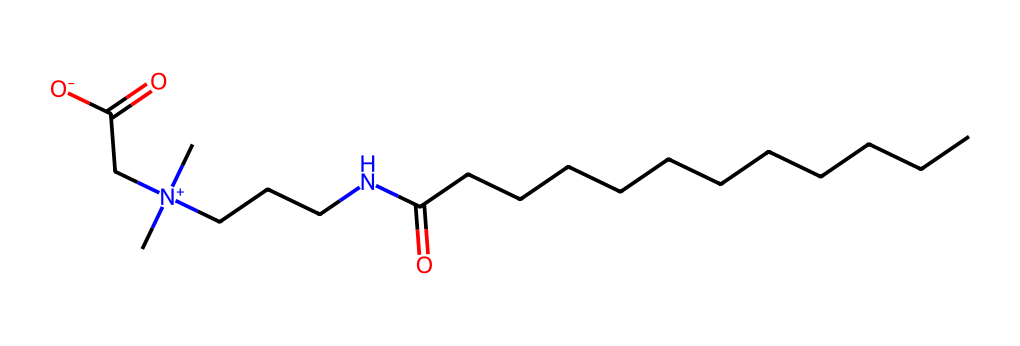What is the total number of carbon atoms in cocamidopropyl betaine? By analyzing the SMILES representation, we can count the carbon atoms present. The chain "CCCCCCCCCCCC" indicates 12 carbon atoms, plus 2 additional carbon atoms from "NCCC" and one more in the "CC(=O)" section, bringing the total to 15 carbon atoms.
Answer: 15 How many nitrogen atoms are present in cocamidopropyl betaine? The SMILES shows "N" in two locations: one in the "NCCC" part and another as "[N+]" in the same sequence. Thus, there are 2 nitrogen atoms in total.
Answer: 2 What type of surfactant is cocamidopropyl betaine? Cocamidopropyl betaine contains a quaternary nitrogen ("[N+]") linked to the hydrocarbon chain. This configuration indicates that it is a cationic surfactant, making it soluble in water and effective in cleaning.
Answer: cationic What functional groups are present in cocamidopropyl betaine? Looking at the SMILES representation, we can identify the ester functional group "C(=O)", the carbonyl group, and the amine from the "N" in "NCCC". This leads to the conclusion that both an amine and a carboxylic acid functional group are present.
Answer: amine and carboxylic acid How does the presence of a quaternary nitrogen influence cocamidopropyl betaine? The presence of the quaternary nitrogen contributes to the surfactant's overall positive charge, enhancing its ability to form micelles, reduce surface tension in water, and improve cleaning capacity. This is especially useful in formulations for personal care products.
Answer: increases cleaning capacity What is the significance of the long carbon chain in cocamidopropyl betaine? The long carbon chain contributes hydrophobic properties to the molecule, allowing it to interact effectively with oils and dirt while the charged head facilitates solubility in water. This amphiphilic nature is crucial for its role as a surfactant.
Answer: amphiphilic properties 